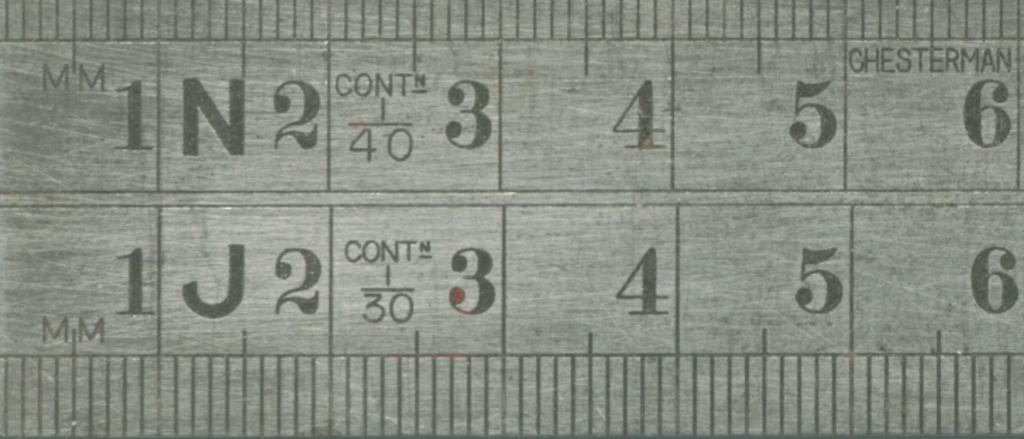<image>
Describe the image concisely. A grey ruler with chesterman written on it 